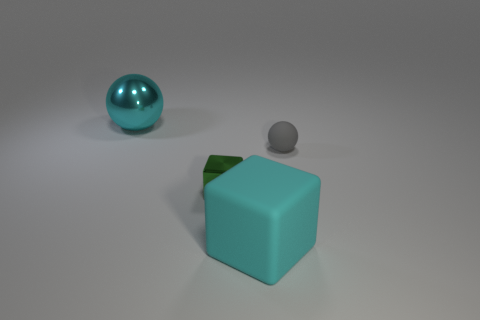What color is the big object that is to the right of the big object that is on the left side of the tiny green thing?
Provide a succinct answer. Cyan. There is a cyan thing that is to the right of the big metallic object; is it the same shape as the large metal object?
Ensure brevity in your answer.  No. How many things are both behind the tiny gray matte thing and in front of the tiny metal block?
Offer a terse response. 0. There is a shiny object that is in front of the small object to the right of the rubber object that is left of the tiny sphere; what is its color?
Provide a succinct answer. Green. There is a large cyan thing on the left side of the large cyan cube; how many balls are right of it?
Offer a terse response. 1. What number of objects are either tiny shiny cubes or things behind the big matte object?
Give a very brief answer. 3. Is the number of cubes behind the cyan cube greater than the number of large shiny things behind the metallic ball?
Keep it short and to the point. Yes. The small rubber thing that is on the right side of the ball that is on the left side of the cyan thing that is in front of the large metal thing is what shape?
Provide a short and direct response. Sphere. What shape is the cyan thing in front of the ball that is behind the small rubber sphere?
Ensure brevity in your answer.  Cube. Is there a cyan thing that has the same material as the gray ball?
Provide a succinct answer. Yes. 